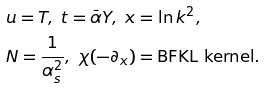Convert formula to latex. <formula><loc_0><loc_0><loc_500><loc_500>& u = T , \ t = \bar { \alpha } Y , \ x = \ln k ^ { 2 } , \\ & N = \frac { 1 } { \alpha _ { s } ^ { 2 } } , \ \chi ( - \partial _ { x } ) = \text {BFKL kernel} .</formula> 